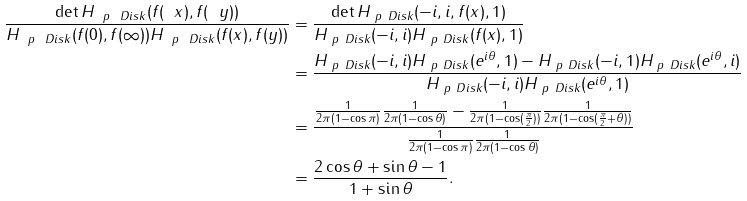Convert formula to latex. <formula><loc_0><loc_0><loc_500><loc_500>\frac { \det H _ { \ p \ D i s k } ( f ( \ x ) , f ( \ y ) ) } { H _ { \ p \ D i s k } ( f ( 0 ) , f ( \infty ) ) H _ { \ p \ D i s k } ( f ( x ) , f ( y ) ) } & = \frac { \det H _ { \ p \ D i s k } ( - i , i , f ( x ) , 1 ) } { H _ { \ p \ D i s k } ( - i , i ) H _ { \ p \ D i s k } ( f ( x ) , 1 ) } \\ & = \frac { H _ { \ p \ D i s k } ( - i , i ) H _ { \ p \ D i s k } ( e ^ { i \theta } , 1 ) - H _ { \ p \ D i s k } ( - i , 1 ) H _ { \ p \ D i s k } ( e ^ { i \theta } , i ) } { H _ { \ p \ D i s k } ( - i , i ) H _ { \ p \ D i s k } ( e ^ { i \theta } , 1 ) } \\ & = \frac { \frac { 1 } { 2 \pi ( 1 - \cos \pi ) } \frac { 1 } { 2 \pi ( 1 - \cos \theta ) } - \frac { 1 } { 2 \pi ( 1 - \cos ( \frac { \pi } { 2 } ) ) } \frac { 1 } { 2 \pi ( 1 - \cos ( \frac { \pi } { 2 } + \theta ) ) } } { \frac { 1 } { 2 \pi ( 1 - \cos \pi ) } \frac { 1 } { 2 \pi ( 1 - \cos \theta ) } } \\ & = \frac { 2 \cos \theta + \sin \theta - 1 } { 1 + \sin \theta } .</formula> 